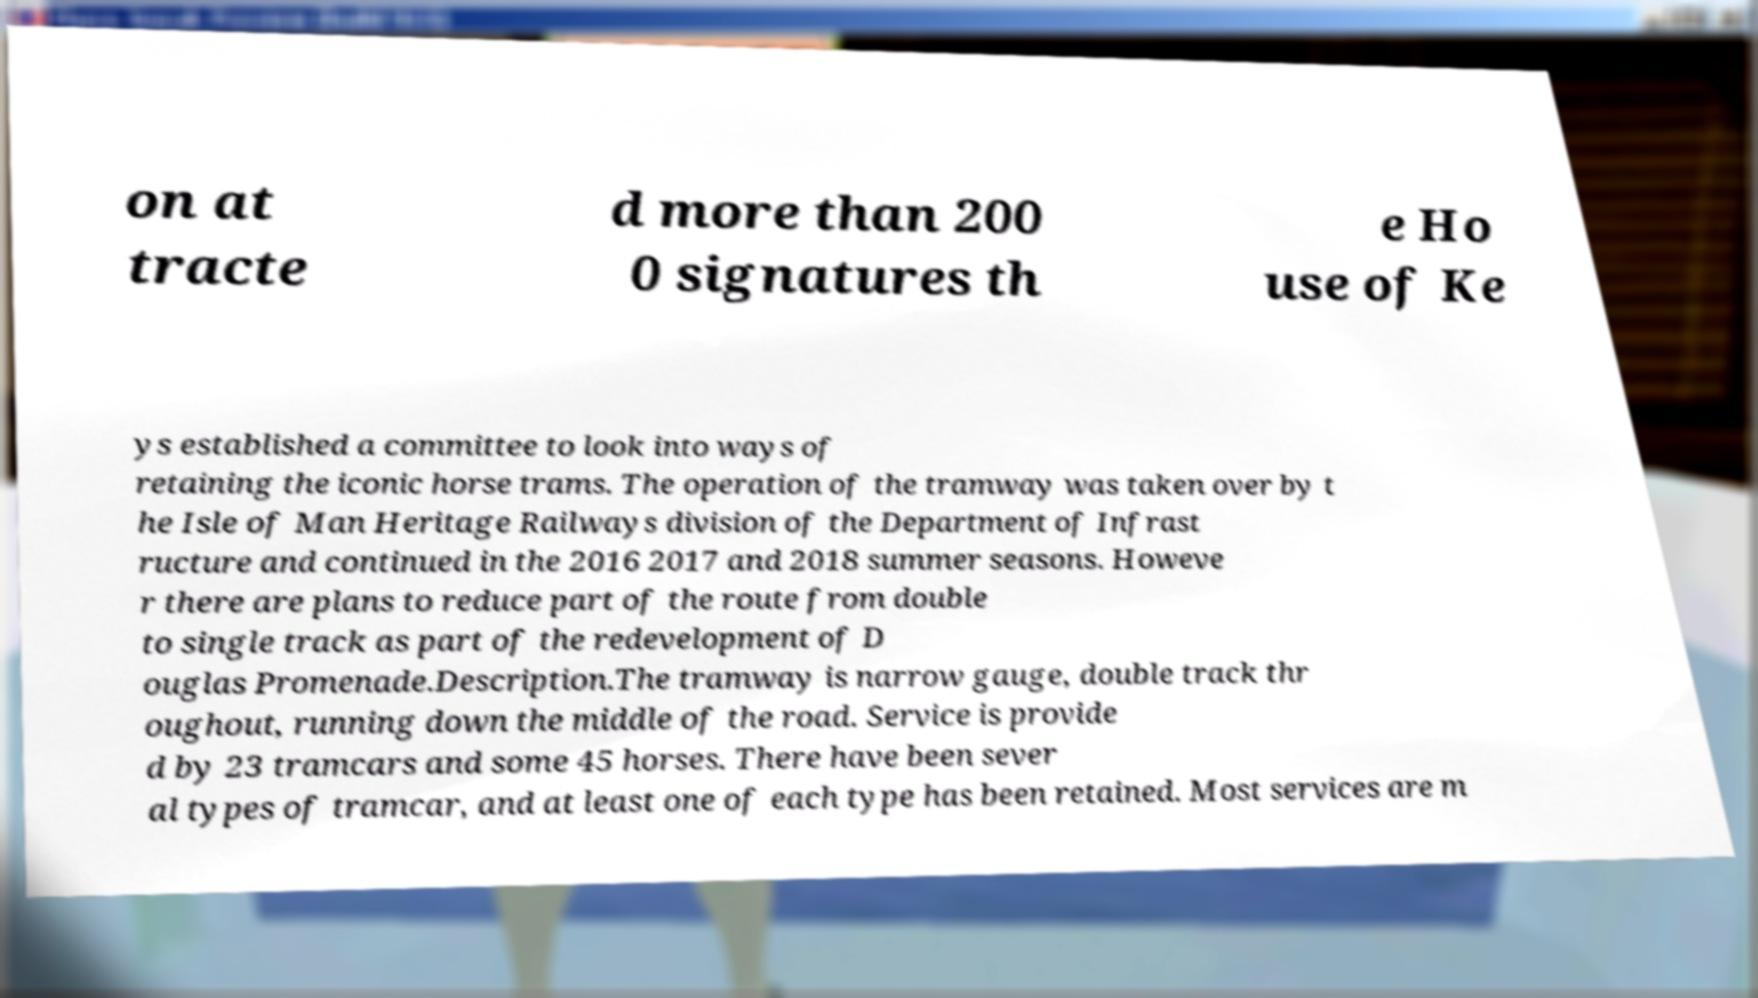Please identify and transcribe the text found in this image. on at tracte d more than 200 0 signatures th e Ho use of Ke ys established a committee to look into ways of retaining the iconic horse trams. The operation of the tramway was taken over by t he Isle of Man Heritage Railways division of the Department of Infrast ructure and continued in the 2016 2017 and 2018 summer seasons. Howeve r there are plans to reduce part of the route from double to single track as part of the redevelopment of D ouglas Promenade.Description.The tramway is narrow gauge, double track thr oughout, running down the middle of the road. Service is provide d by 23 tramcars and some 45 horses. There have been sever al types of tramcar, and at least one of each type has been retained. Most services are m 